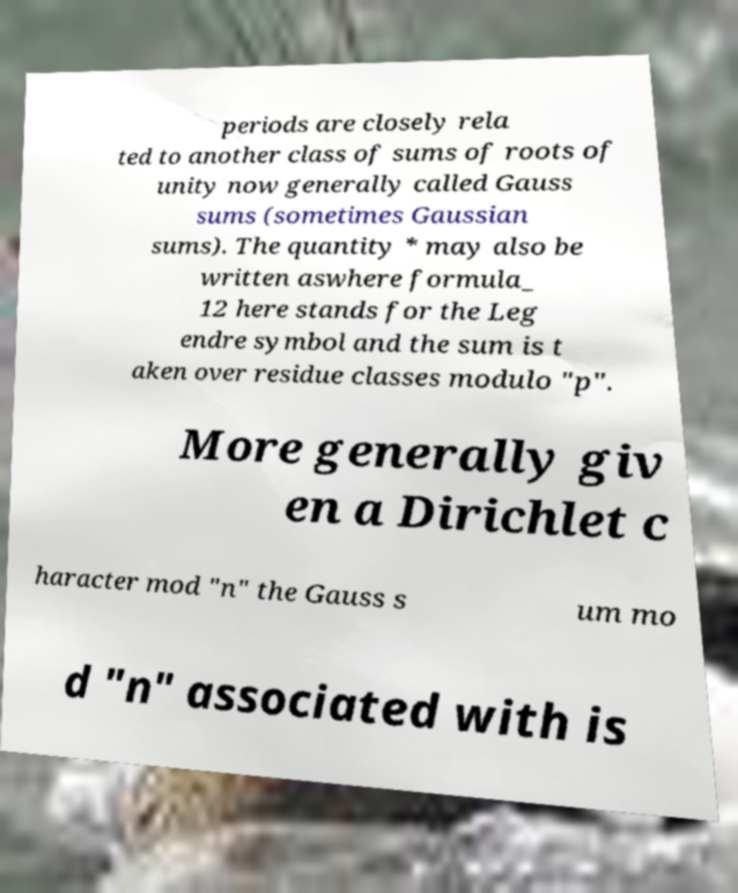For documentation purposes, I need the text within this image transcribed. Could you provide that? periods are closely rela ted to another class of sums of roots of unity now generally called Gauss sums (sometimes Gaussian sums). The quantity * may also be written aswhere formula_ 12 here stands for the Leg endre symbol and the sum is t aken over residue classes modulo "p". More generally giv en a Dirichlet c haracter mod "n" the Gauss s um mo d "n" associated with is 